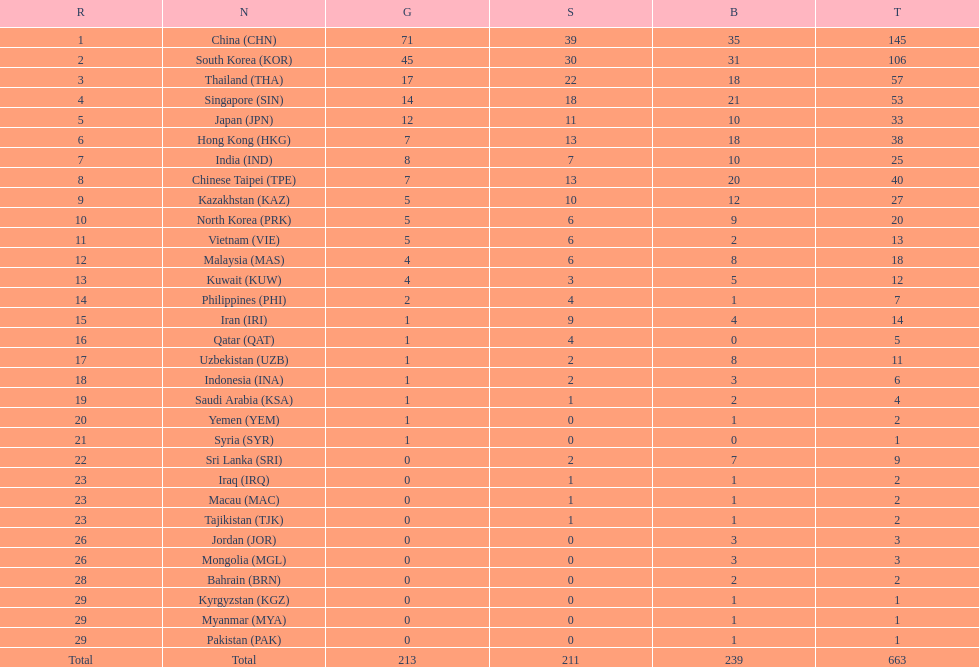How many nations earned at least ten bronze medals? 9. 